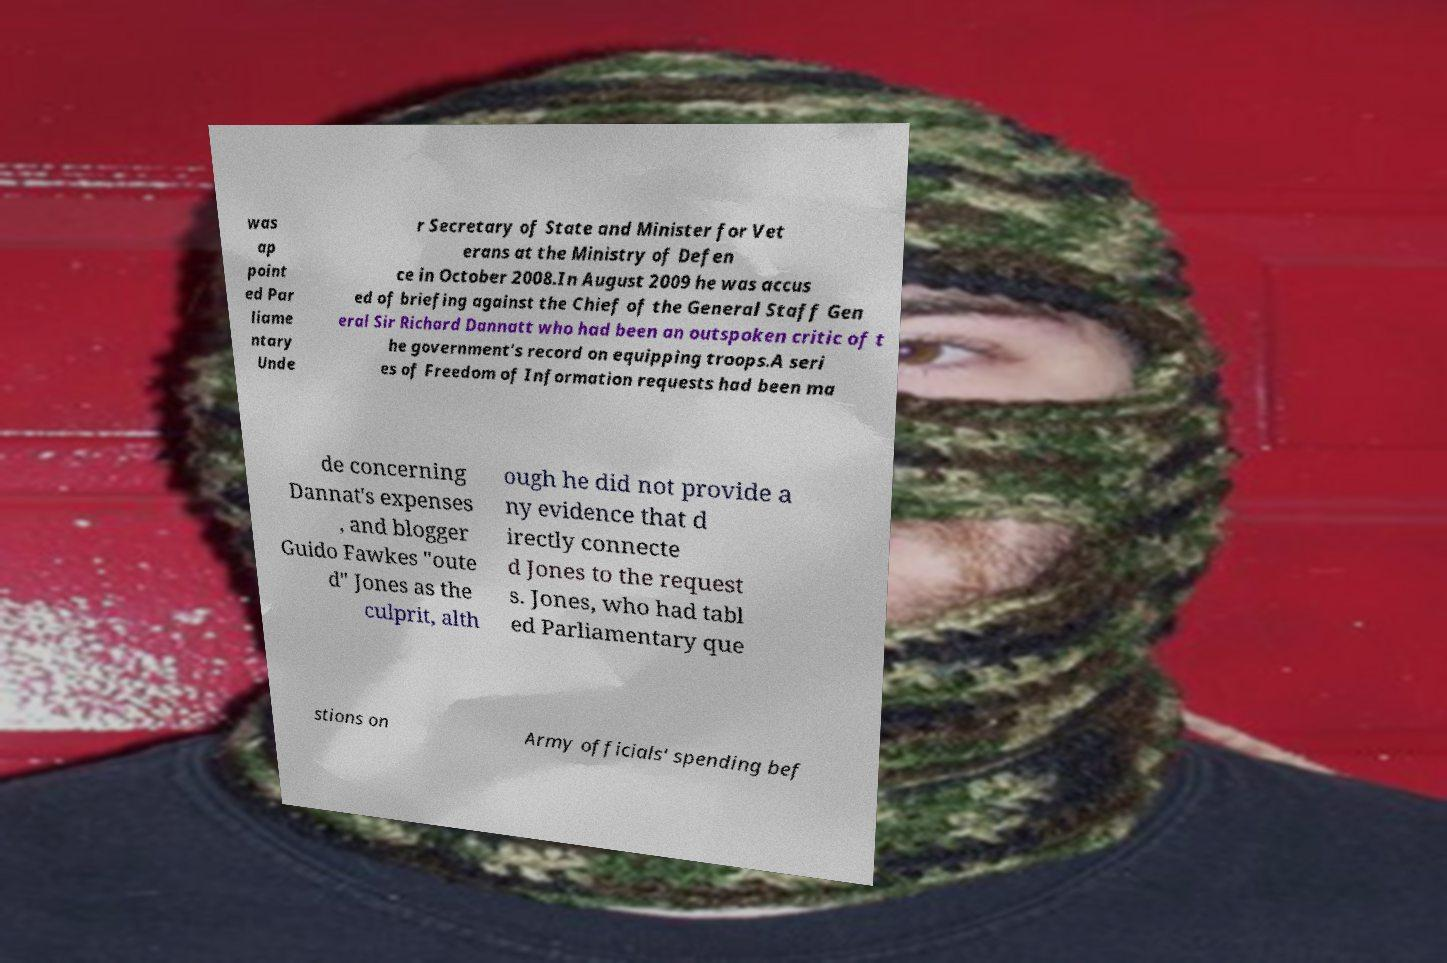Please identify and transcribe the text found in this image. was ap point ed Par liame ntary Unde r Secretary of State and Minister for Vet erans at the Ministry of Defen ce in October 2008.In August 2009 he was accus ed of briefing against the Chief of the General Staff Gen eral Sir Richard Dannatt who had been an outspoken critic of t he government's record on equipping troops.A seri es of Freedom of Information requests had been ma de concerning Dannat's expenses , and blogger Guido Fawkes "oute d" Jones as the culprit, alth ough he did not provide a ny evidence that d irectly connecte d Jones to the request s. Jones, who had tabl ed Parliamentary que stions on Army officials' spending bef 